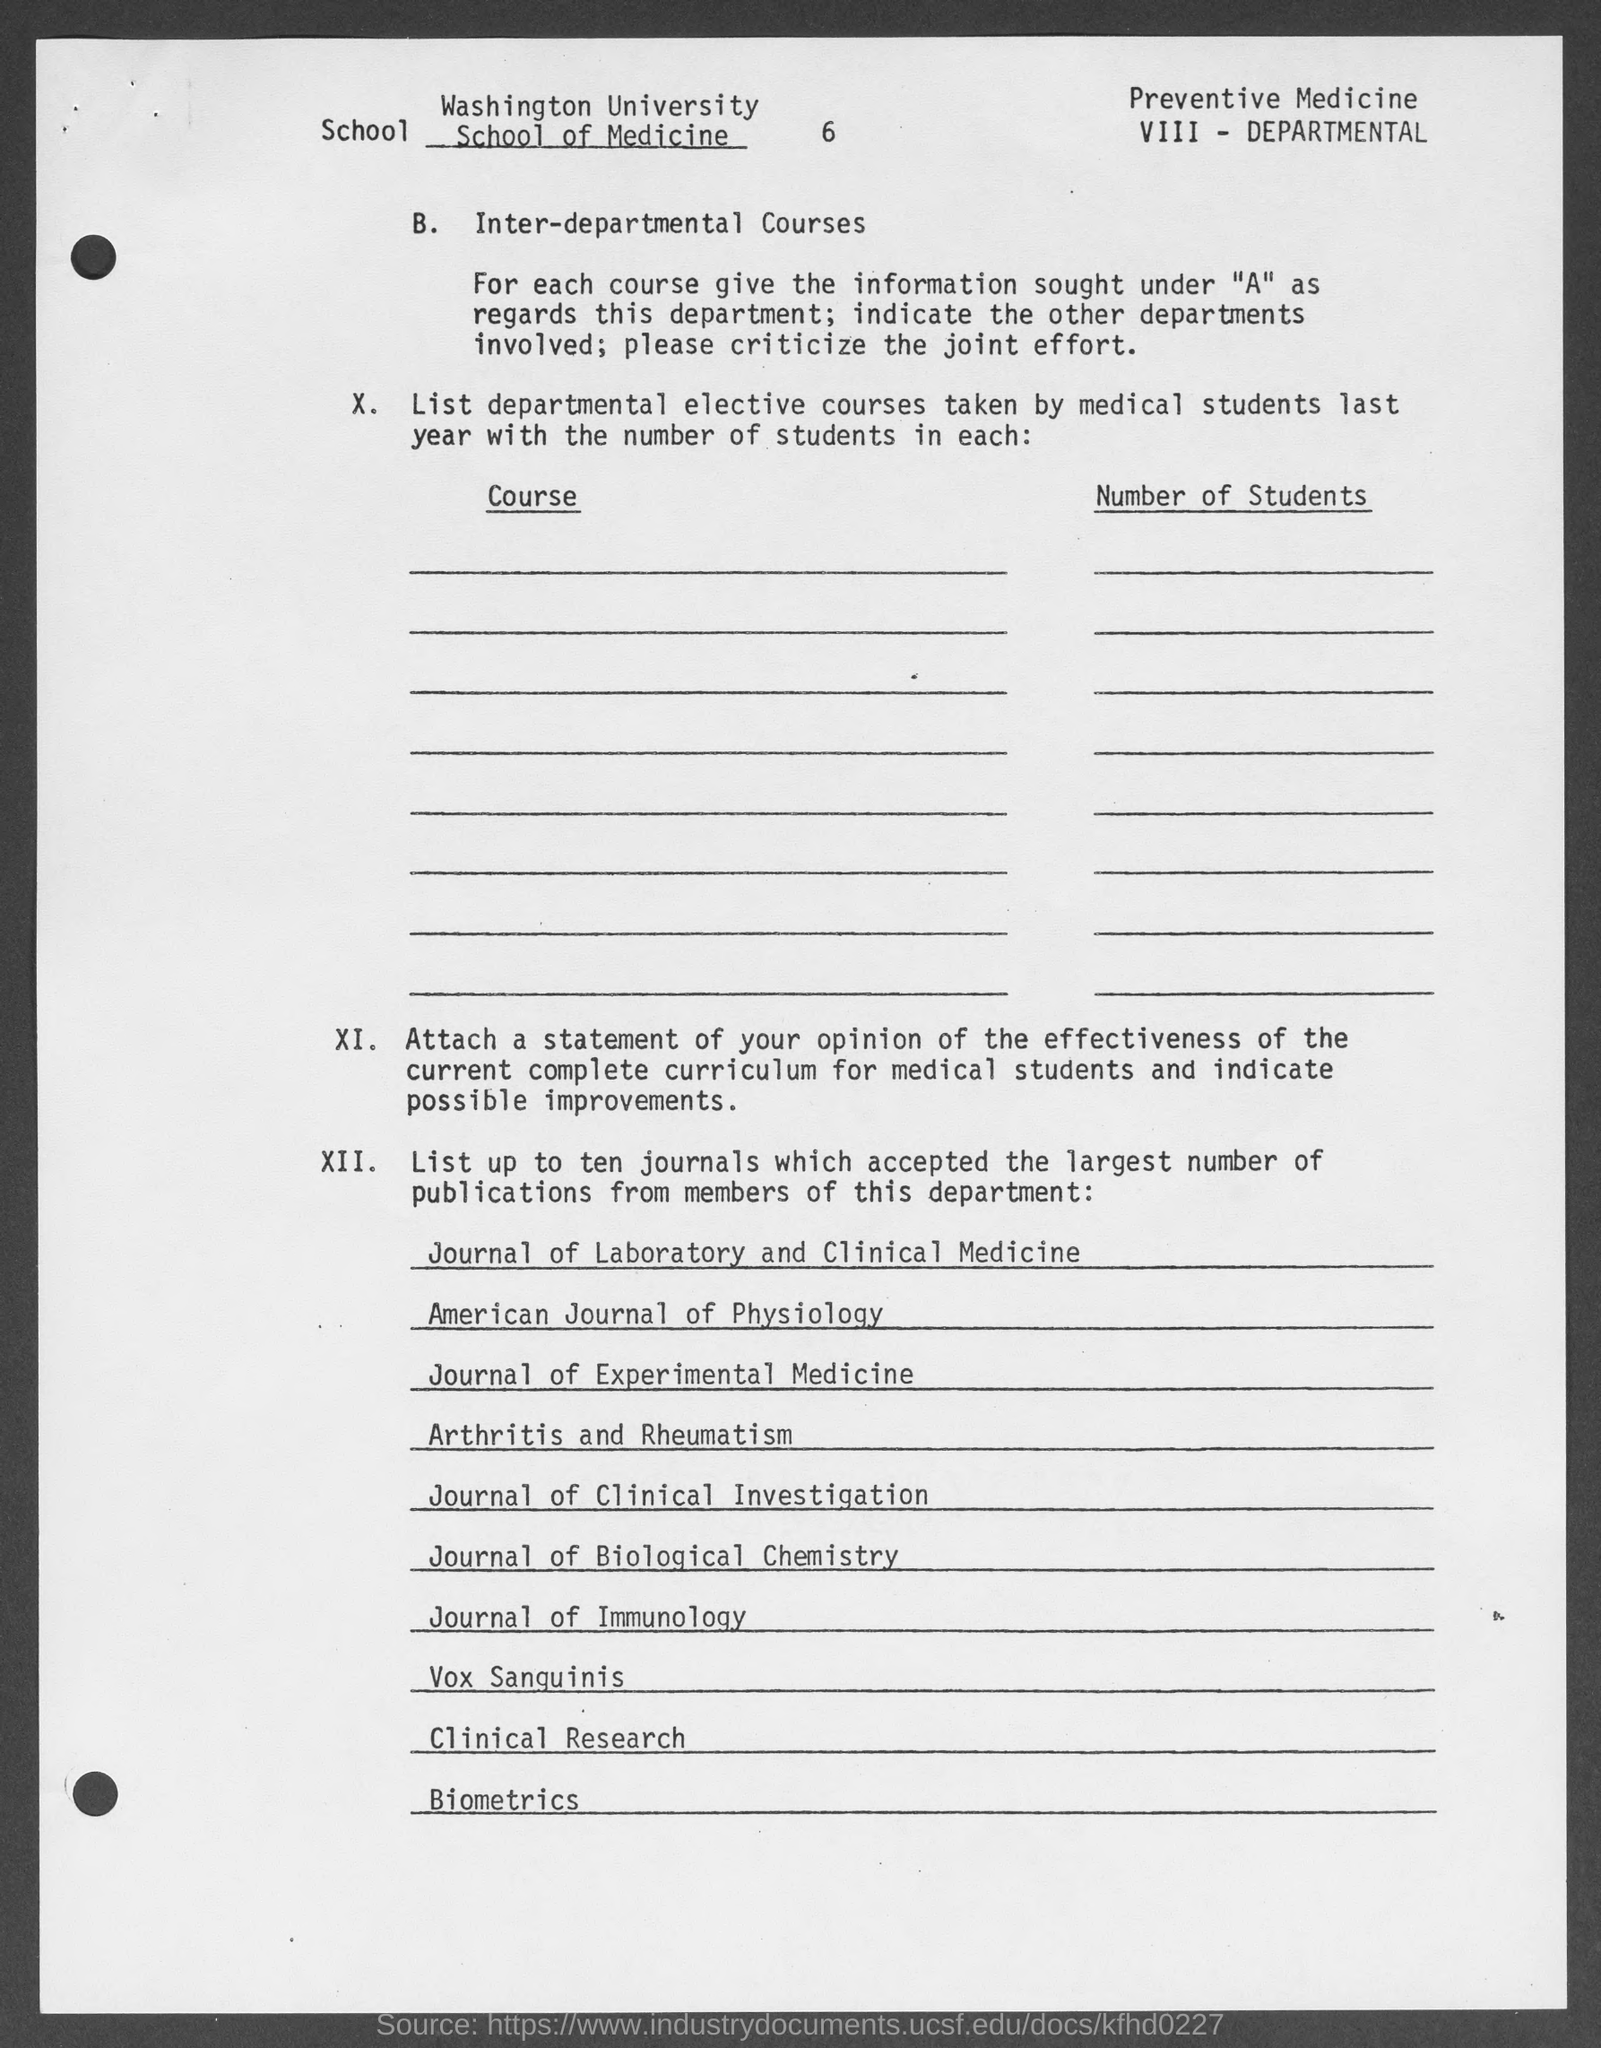What is the number at top of the document ?
Your answer should be very brief. 6. 